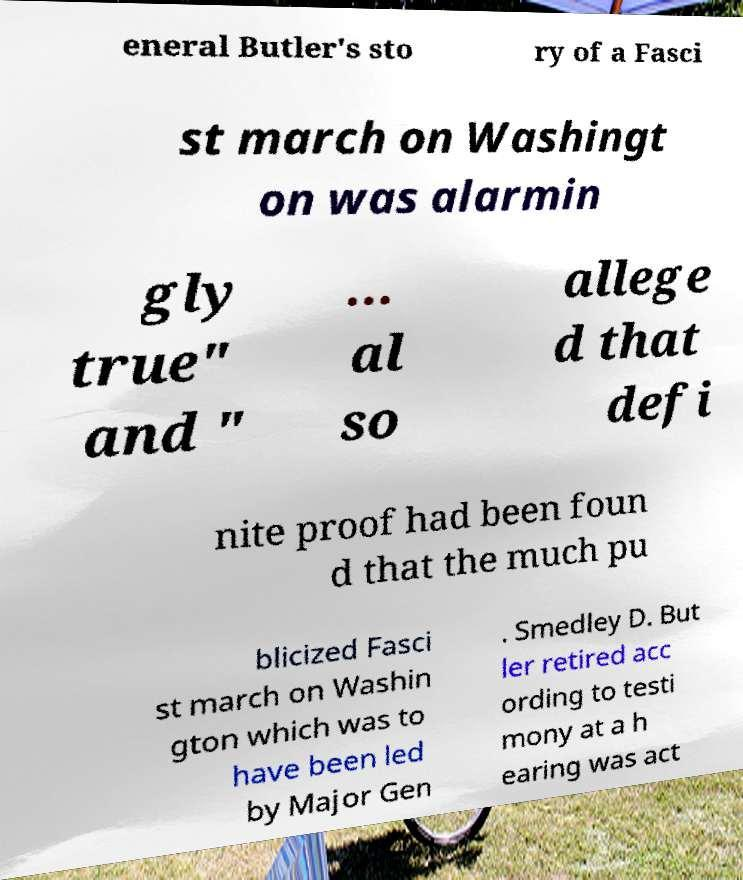For documentation purposes, I need the text within this image transcribed. Could you provide that? eneral Butler's sto ry of a Fasci st march on Washingt on was alarmin gly true" and " ... al so allege d that defi nite proof had been foun d that the much pu blicized Fasci st march on Washin gton which was to have been led by Major Gen . Smedley D. But ler retired acc ording to testi mony at a h earing was act 